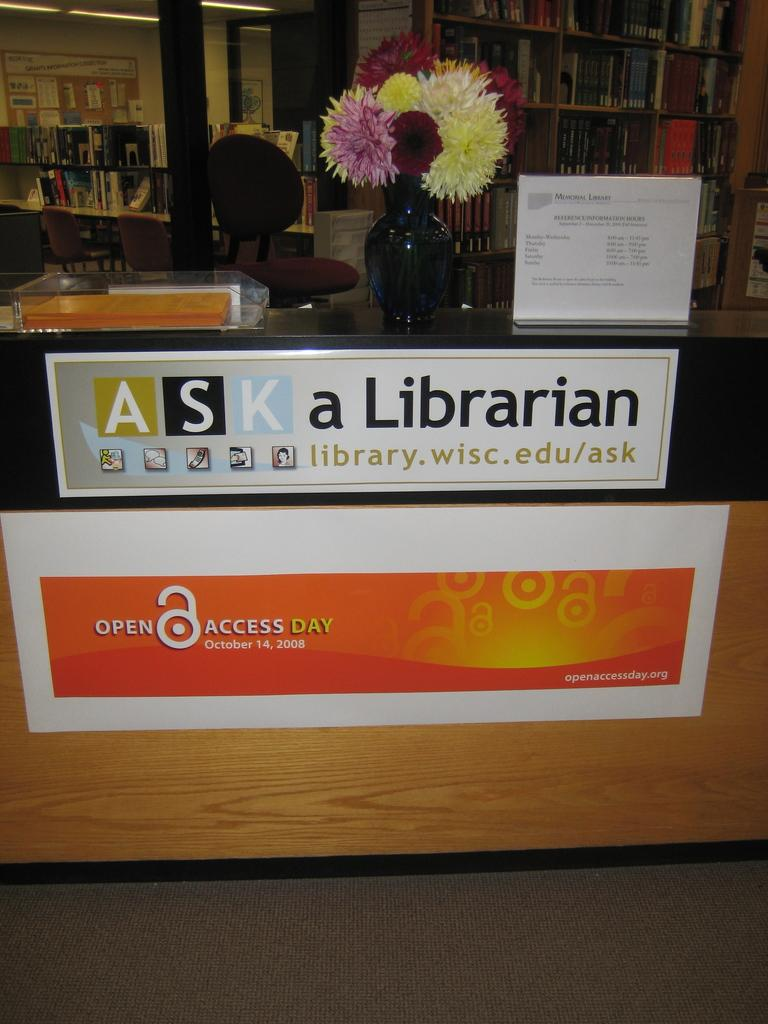<image>
Provide a brief description of the given image. A sign in a library that says "ASK a Librarian" Open Access Day, October 14, 2008 